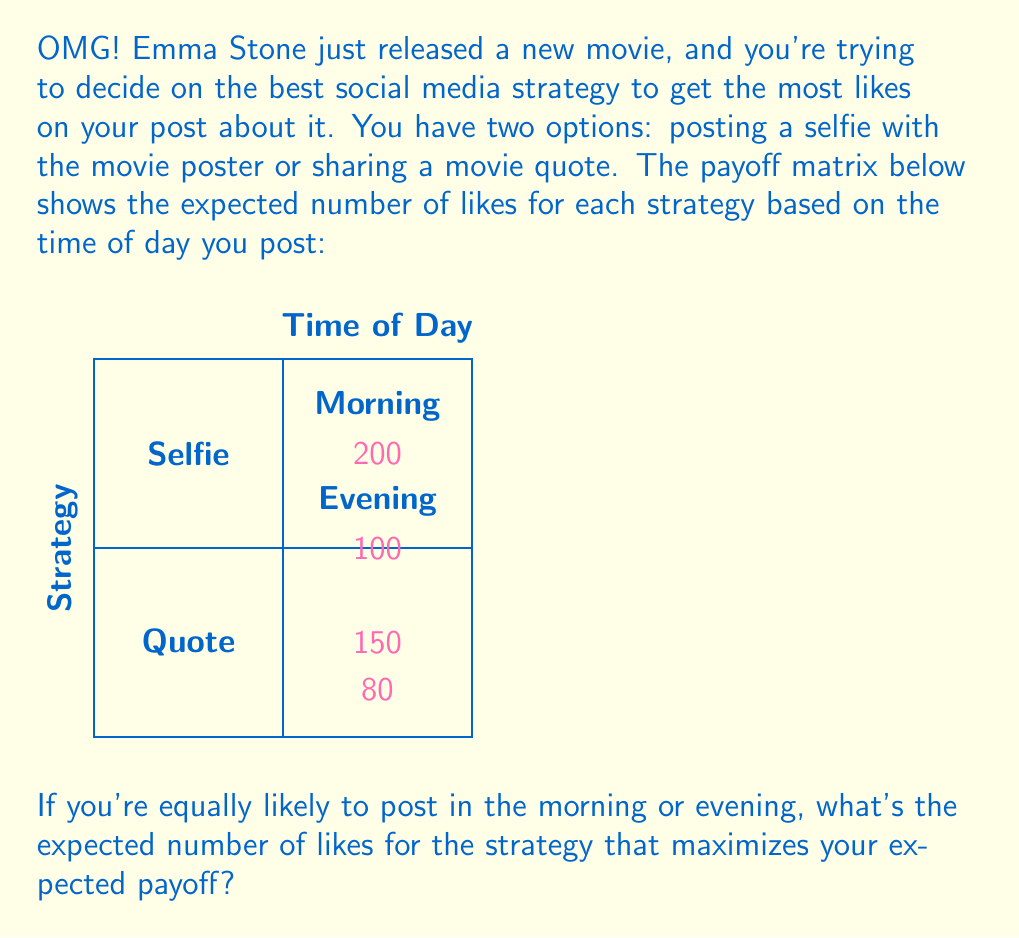Show me your answer to this math problem. Let's approach this step-by-step:

1) First, we need to calculate the expected payoff for each strategy:

   For Selfie:
   $E(\text{Selfie}) = 0.5 \times 200 + 0.5 \times 100 = 150$

   For Quote:
   $E(\text{Quote}) = 0.5 \times 80 + 0.5 \times 150 = 115$

2) The strategy that maximizes the expected payoff is the one with the higher expected value. In this case, it's the Selfie strategy with an expected payoff of 150 likes.

3) Therefore, the expected number of likes for the strategy that maximizes your expected payoff is 150.

This approach uses the concept of expected value from decision theory, where we multiply each outcome by its probability and sum these products to get the expected value of a strategy.
Answer: 150 likes 